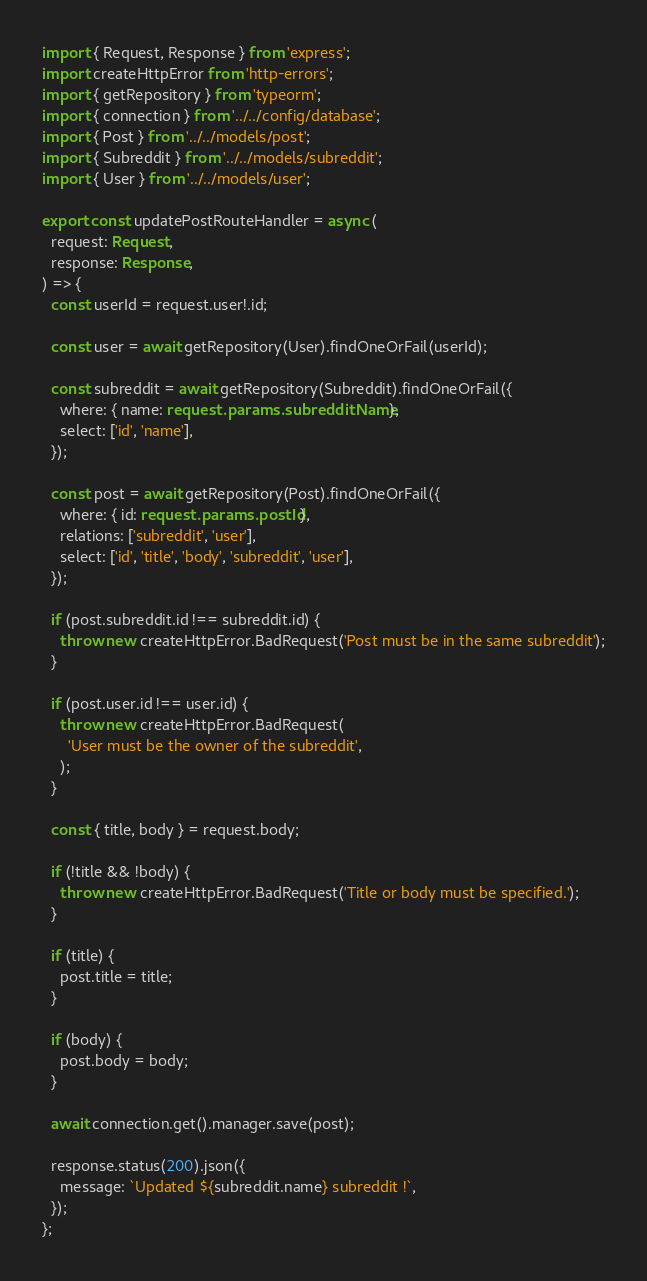<code> <loc_0><loc_0><loc_500><loc_500><_TypeScript_>import { Request, Response } from 'express';
import createHttpError from 'http-errors';
import { getRepository } from 'typeorm';
import { connection } from '../../config/database';
import { Post } from '../../models/post';
import { Subreddit } from '../../models/subreddit';
import { User } from '../../models/user';

export const updatePostRouteHandler = async (
  request: Request,
  response: Response,
) => {
  const userId = request.user!.id;

  const user = await getRepository(User).findOneOrFail(userId);

  const subreddit = await getRepository(Subreddit).findOneOrFail({
    where: { name: request.params.subredditName },
    select: ['id', 'name'],
  });

  const post = await getRepository(Post).findOneOrFail({
    where: { id: request.params.postId },
    relations: ['subreddit', 'user'],
    select: ['id', 'title', 'body', 'subreddit', 'user'],
  });

  if (post.subreddit.id !== subreddit.id) {
    throw new createHttpError.BadRequest('Post must be in the same subreddit');
  }

  if (post.user.id !== user.id) {
    throw new createHttpError.BadRequest(
      'User must be the owner of the subreddit',
    );
  }

  const { title, body } = request.body;

  if (!title && !body) {
    throw new createHttpError.BadRequest('Title or body must be specified.');
  }

  if (title) {
    post.title = title;
  }

  if (body) {
    post.body = body;
  }

  await connection.get().manager.save(post);

  response.status(200).json({
    message: `Updated ${subreddit.name} subreddit !`,
  });
};
</code> 